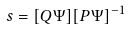Convert formula to latex. <formula><loc_0><loc_0><loc_500><loc_500>s = [ Q \Psi ] [ P \Psi ] ^ { - 1 }</formula> 